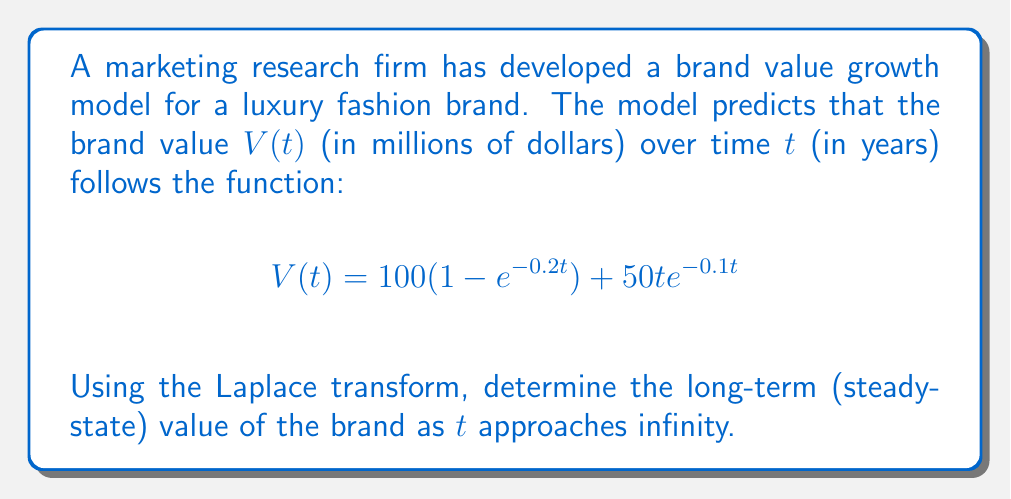Show me your answer to this math problem. To solve this problem, we'll use the Laplace transform and its final value theorem. The steps are as follows:

1) First, recall the final value theorem:
   $$\lim_{t \to \infty} f(t) = \lim_{s \to 0} sF(s)$$
   where $F(s)$ is the Laplace transform of $f(t)$.

2) We need to find the Laplace transform of $V(t)$. Let's break it into two parts:
   $$V(t) = V_1(t) + V_2(t)$$
   where $V_1(t) = 100(1 - e^{-0.2t})$ and $V_2(t) = 50t e^{-0.1t}$

3) For $V_1(t)$:
   $$\mathcal{L}\{V_1(t)\} = 100 \cdot \mathcal{L}\{1 - e^{-0.2t}\} = 100 \cdot (\frac{1}{s} - \frac{1}{s+0.2}) = \frac{20}{s(s+0.2)}$$

4) For $V_2(t)$:
   $$\mathcal{L}\{V_2(t)\} = 50 \cdot \mathcal{L}\{t e^{-0.1t}\} = 50 \cdot \frac{1}{(s+0.1)^2}$$

5) The total Laplace transform $V(s)$ is:
   $$V(s) = \frac{20}{s(s+0.2)} + \frac{50}{(s+0.1)^2}$$

6) Now, applying the final value theorem:
   $$\lim_{t \to \infty} V(t) = \lim_{s \to 0} sV(s)$$

7) Calculating the limit:
   $$\lim_{s \to 0} s(\frac{20}{s(s+0.2)} + \frac{50}{(s+0.1)^2})$$
   $$= \lim_{s \to 0} (\frac{20}{s+0.2} + \frac{50s}{(s+0.1)^2})$$
   $$= \frac{20}{0.2} + \frac{50 \cdot 0}{(0.1)^2} = 100$$

Therefore, the long-term (steady-state) value of the brand as $t$ approaches infinity is 100 million dollars.
Answer: $100 million 